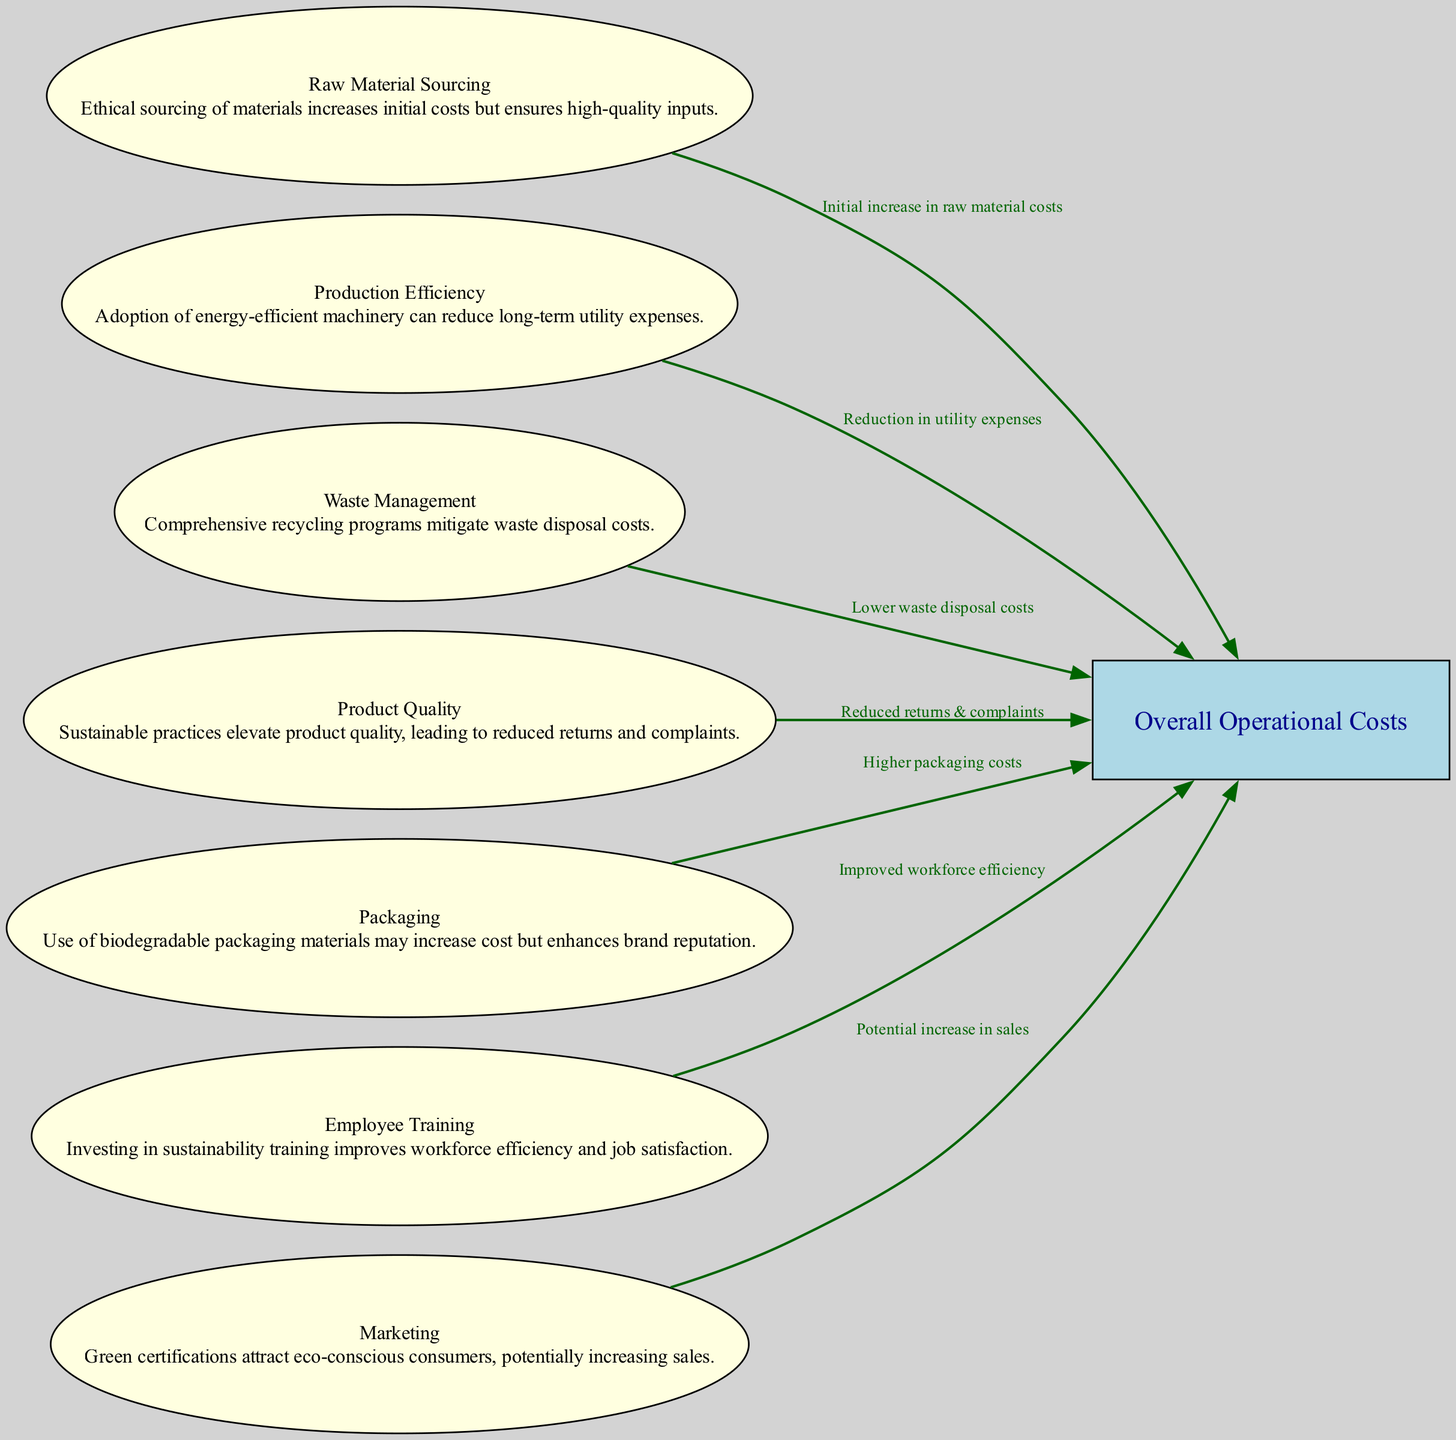What is the label of the final node? The final node is labeled "Overall Operational Costs". This can be found in the list of nodes provided in the data.
Answer: Overall Operational Costs How many nodes are in the diagram? By counting the number of distinct nodes listed in the data, there are eight nodes total.
Answer: 8 What increases in initial costs according to the diagram? The edge from "Raw Material Sourcing" specifies that there is an "Initial increase in raw material costs". This describes the relationship highlighted in the diagram.
Answer: Initial increase in raw material costs Which practice is linked to "Reduction in utility expenses"? The edge from "Production Efficiency" connects directly to "Overall Operational Costs" and states it leads to a "Reduction in utility expenses". This indicates the impact of adopting energy-efficient machinery.
Answer: Production Efficiency What do sustainability practices do to long-term operational costs? According to the "Overall Operational Costs" node, the content states "Long-term cost savings through sustainability practices can offset initial investments", confirming the positive impact of sustainable practices on costs over time.
Answer: Offset initial investments Which node mentions comprehensive recycling programs? The "Waste Management" node discusses "Comprehensive recycling programs", as indicated in the node's content. This directly states how recycling efforts contribute to operational costs.
Answer: Waste Management How does employee training impact operational costs? The "Employee Training" node mentions "Improved workforce efficiency", which suggests that investing in training can lead to reduced costs related to inefficiency in operational processes.
Answer: Improved workforce efficiency Which node refers to packaging with a potential increase in costs? The "Packaging" node mentions the use of biodegradable packaging materials and notes that there may be "Higher packaging costs", as stated in the node.
Answer: Packaging What is the potential benefit of green certifications mentioned in the diagram? According to the "Marketing" node, "Green certifications attract eco-conscious consumers, potentially increasing sales" shows how sustainable marketing practices can have a positive impact on revenue.
Answer: Potential increase in sales 